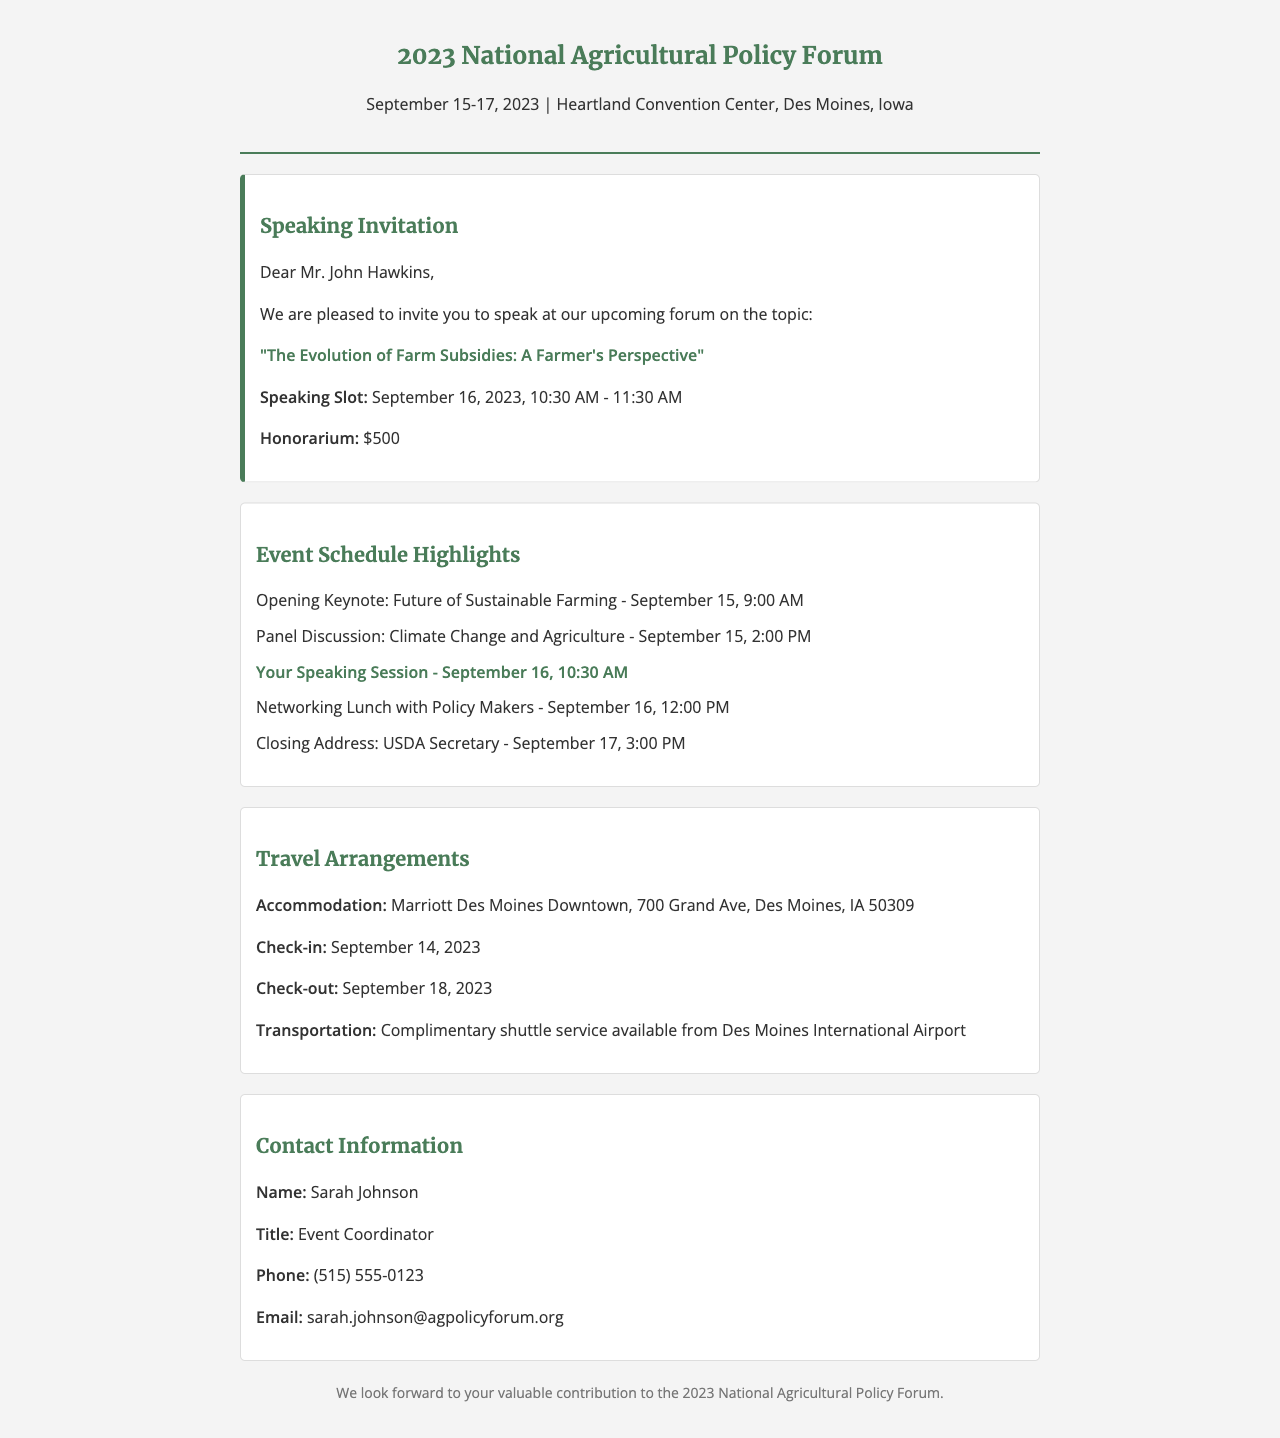What are the dates of the forum? The document states the forum will take place from September 15 to September 17, 2023.
Answer: September 15-17, 2023 What is the title of the speaking topic? The document highlights the speaking topic as "The Evolution of Farm Subsidies: A Farmer's Perspective."
Answer: The Evolution of Farm Subsidies: A Farmer's Perspective What is the honorarium amount for speaking? The document specifies that the honorarium for the speaking engagement is $500.
Answer: $500 When is the speaker's session scheduled? The document indicates that the speaker's session is on September 16, 2023, from 10:30 AM to 11:30 AM.
Answer: September 16, 2023, 10:30 AM - 11:30 AM Who is the event coordinator? The document lists Sarah Johnson as the event coordinator for the forum.
Answer: Sarah Johnson What is the check-in date for accommodation? According to the document, the check-in date for accommodation is September 14, 2023.
Answer: September 14, 2023 What type of service is offered from the airport? The document mentions that complimentary shuttle service is available from Des Moines International Airport.
Answer: Complimentary shuttle service What is the location of the event? The document states that the event will be held at the Heartland Convention Center, Des Moines, Iowa.
Answer: Heartland Convention Center, Des Moines, Iowa What time is the closing address? The document specifies that the closing address is scheduled for September 17 at 3:00 PM.
Answer: 3:00 PM 